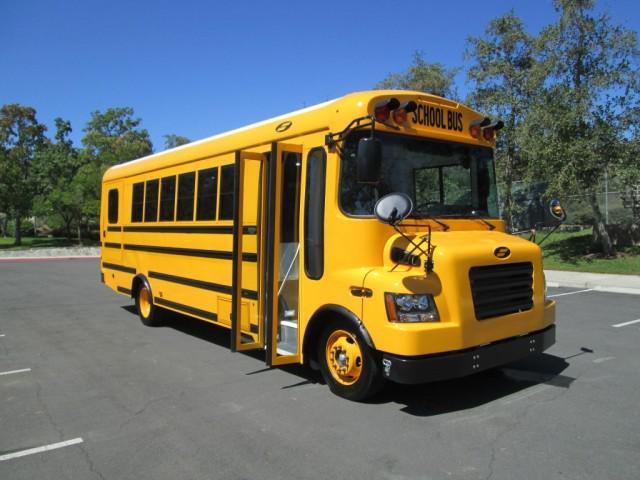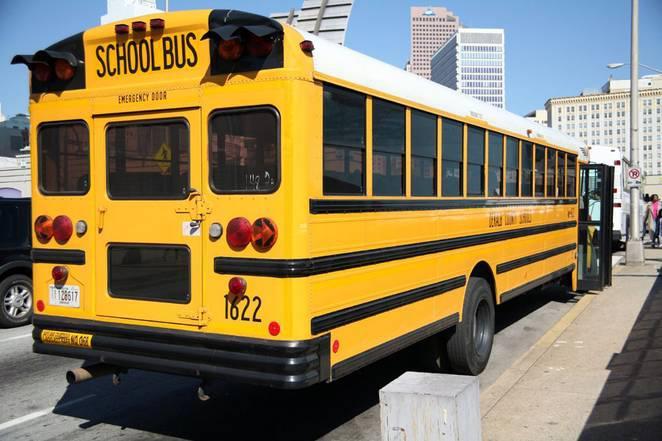The first image is the image on the left, the second image is the image on the right. Assess this claim about the two images: "The left side of a bus is visible.". Correct or not? Answer yes or no. No. 